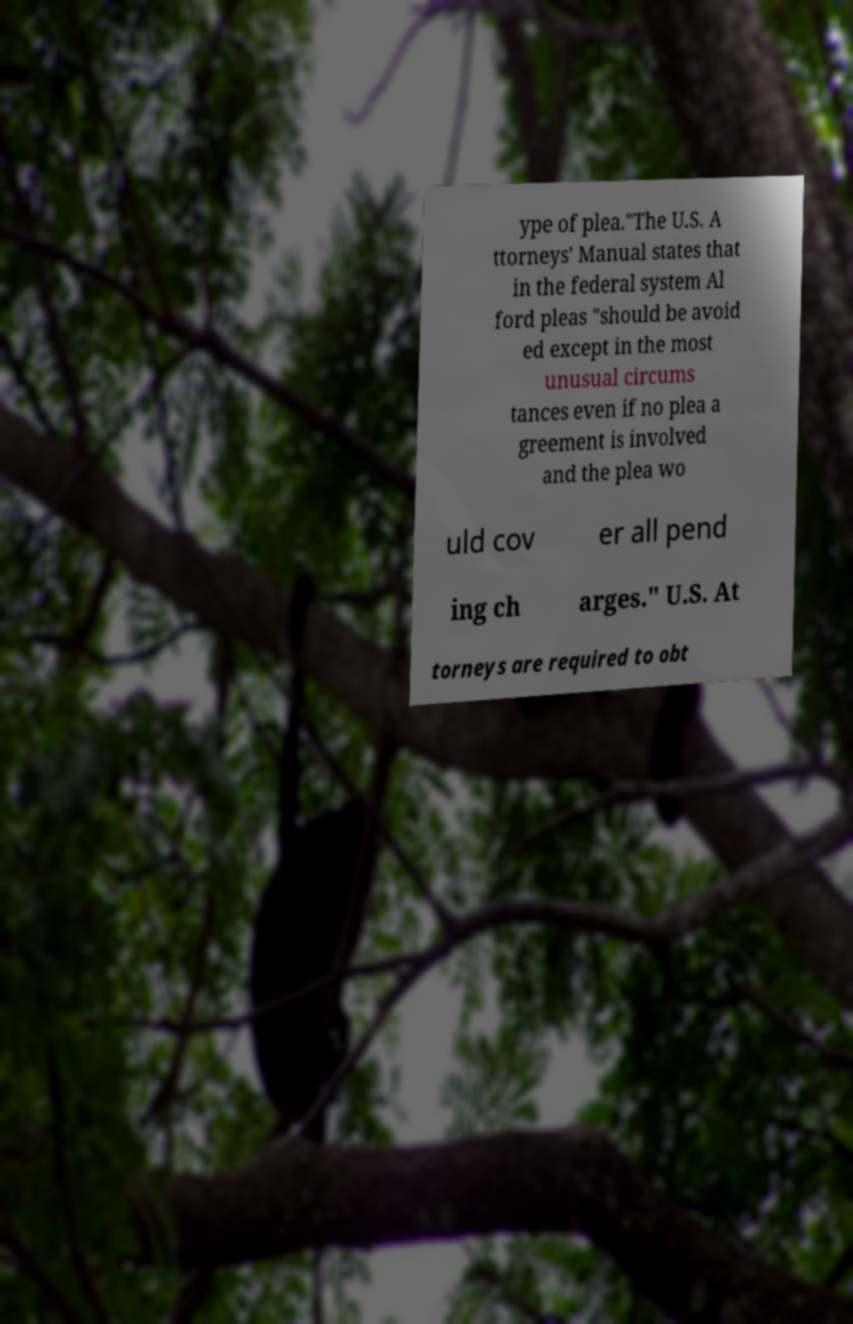Can you read and provide the text displayed in the image?This photo seems to have some interesting text. Can you extract and type it out for me? ype of plea."The U.S. A ttorneys' Manual states that in the federal system Al ford pleas "should be avoid ed except in the most unusual circums tances even if no plea a greement is involved and the plea wo uld cov er all pend ing ch arges." U.S. At torneys are required to obt 